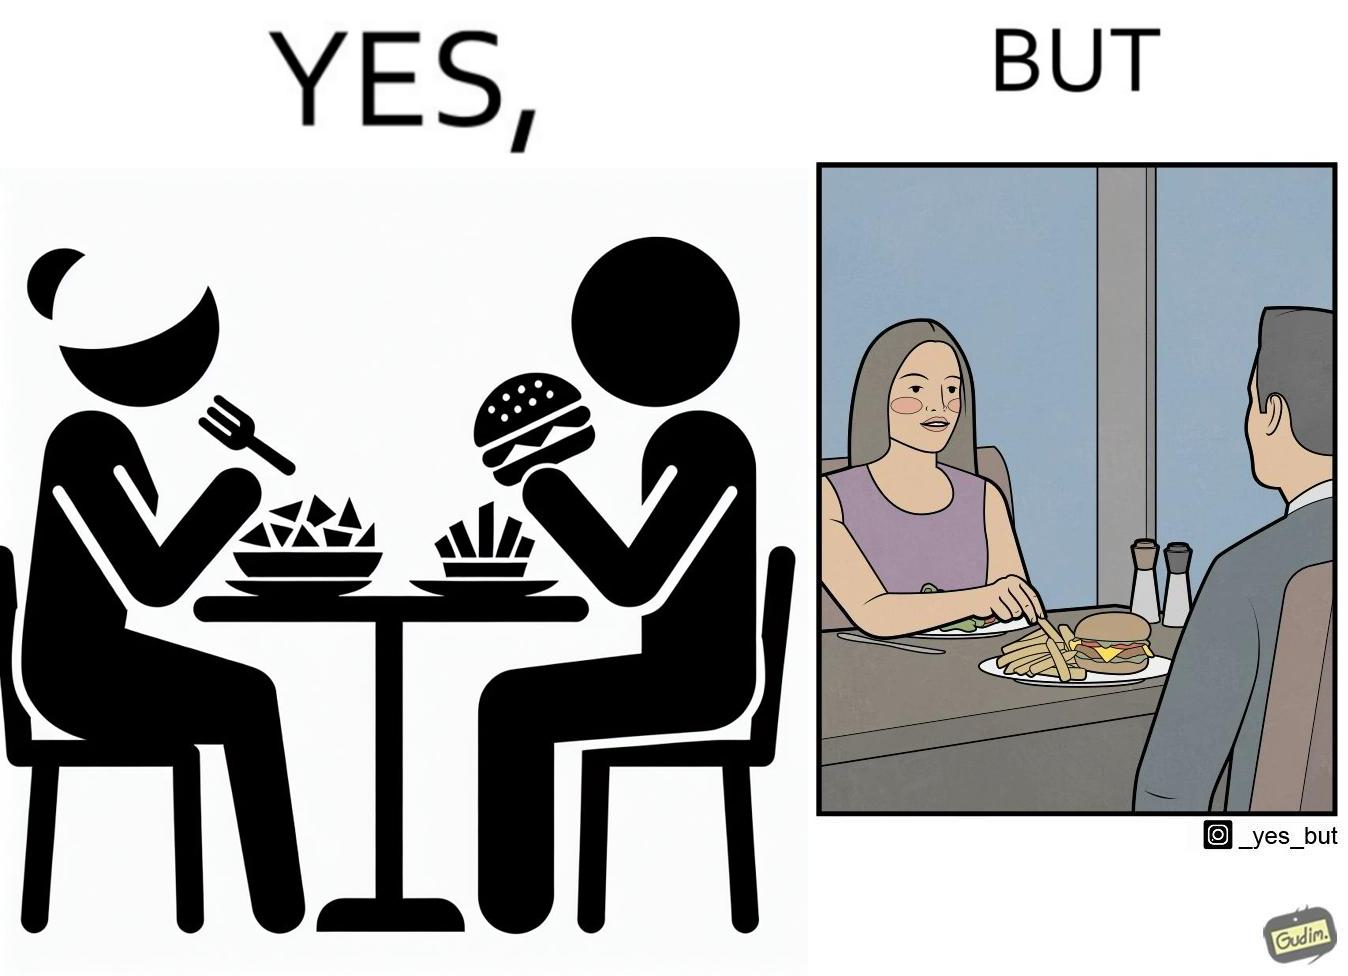Compare the left and right sides of this image. In the left part of the image: a woman and a man having their meals at some restaurant, with a plate of salad on the woman's side and a burger and french fries on the man's side on the table In the right part of the image: a woman and a man having their meals at some restaurant, with a plate of salad on the woman's side and a burger and french fries on the man's side on the table and the woman is having the french fries from the man's plate 